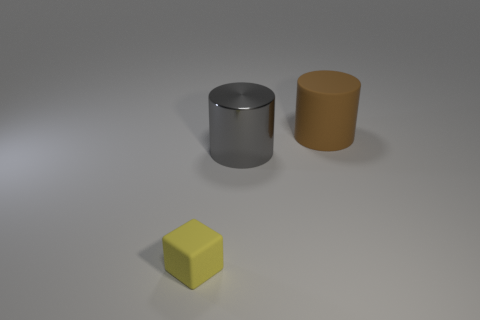Add 3 brown things. How many objects exist? 6 Subtract all cylinders. How many objects are left? 1 Subtract all brown rubber things. Subtract all gray cylinders. How many objects are left? 1 Add 1 yellow matte things. How many yellow matte things are left? 2 Add 2 large gray metal cylinders. How many large gray metal cylinders exist? 3 Subtract 0 red cubes. How many objects are left? 3 Subtract all brown cylinders. Subtract all purple spheres. How many cylinders are left? 1 Subtract all purple cubes. How many gray cylinders are left? 1 